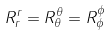<formula> <loc_0><loc_0><loc_500><loc_500>R _ { r } ^ { r } = R _ { \theta } ^ { \theta } = R _ { \phi } ^ { \phi }</formula> 